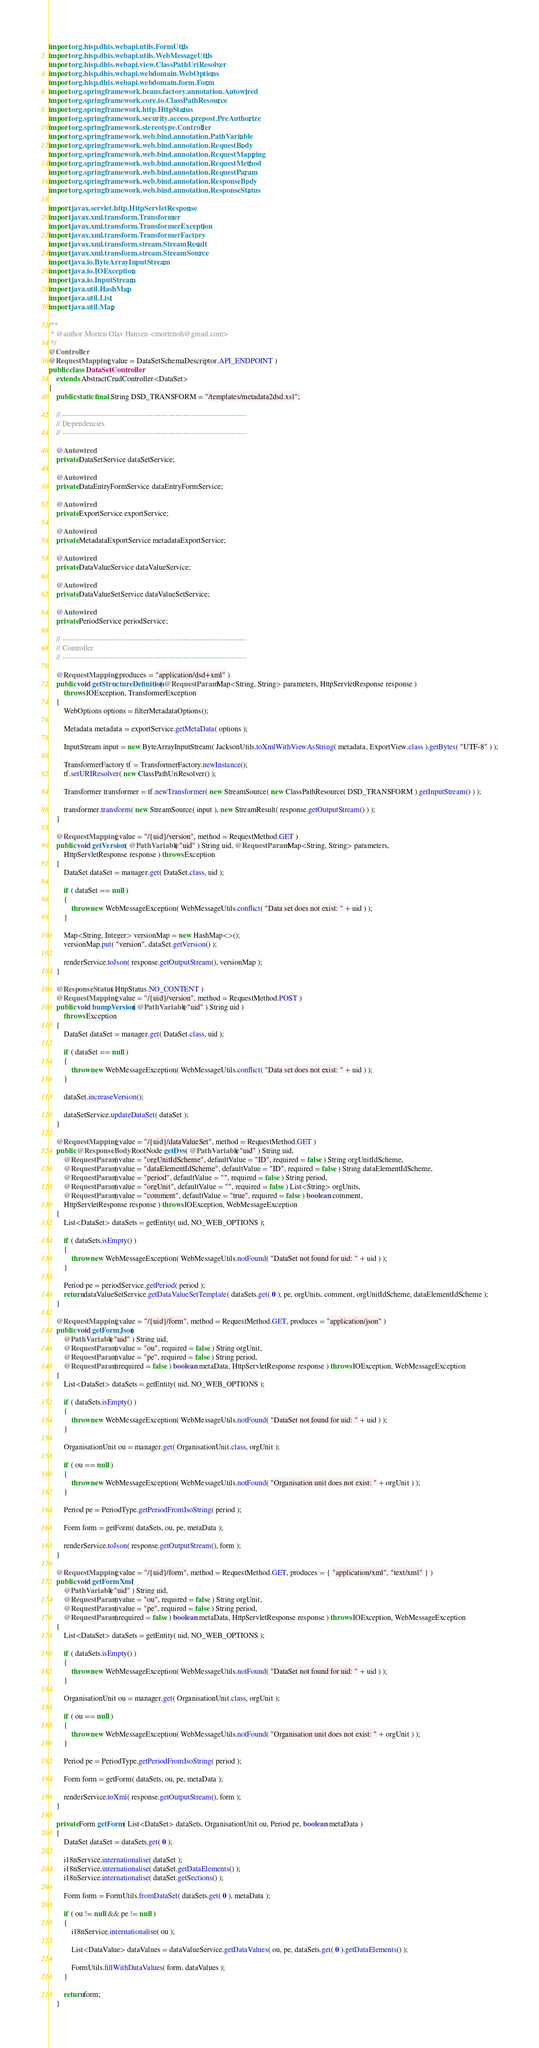Convert code to text. <code><loc_0><loc_0><loc_500><loc_500><_Java_>import org.hisp.dhis.webapi.utils.FormUtils;
import org.hisp.dhis.webapi.utils.WebMessageUtils;
import org.hisp.dhis.webapi.view.ClassPathUriResolver;
import org.hisp.dhis.webapi.webdomain.WebOptions;
import org.hisp.dhis.webapi.webdomain.form.Form;
import org.springframework.beans.factory.annotation.Autowired;
import org.springframework.core.io.ClassPathResource;
import org.springframework.http.HttpStatus;
import org.springframework.security.access.prepost.PreAuthorize;
import org.springframework.stereotype.Controller;
import org.springframework.web.bind.annotation.PathVariable;
import org.springframework.web.bind.annotation.RequestBody;
import org.springframework.web.bind.annotation.RequestMapping;
import org.springframework.web.bind.annotation.RequestMethod;
import org.springframework.web.bind.annotation.RequestParam;
import org.springframework.web.bind.annotation.ResponseBody;
import org.springframework.web.bind.annotation.ResponseStatus;

import javax.servlet.http.HttpServletResponse;
import javax.xml.transform.Transformer;
import javax.xml.transform.TransformerException;
import javax.xml.transform.TransformerFactory;
import javax.xml.transform.stream.StreamResult;
import javax.xml.transform.stream.StreamSource;
import java.io.ByteArrayInputStream;
import java.io.IOException;
import java.io.InputStream;
import java.util.HashMap;
import java.util.List;
import java.util.Map;

/**
 * @author Morten Olav Hansen <mortenoh@gmail.com>
 */
@Controller
@RequestMapping( value = DataSetSchemaDescriptor.API_ENDPOINT )
public class DataSetController
    extends AbstractCrudController<DataSet>
{
    public static final String DSD_TRANSFORM = "/templates/metadata2dsd.xsl";

    // -------------------------------------------------------------------------
    // Dependencies
    // -------------------------------------------------------------------------

    @Autowired
    private DataSetService dataSetService;

    @Autowired
    private DataEntryFormService dataEntryFormService;

    @Autowired
    private ExportService exportService;

    @Autowired
    private MetadataExportService metadataExportService;

    @Autowired
    private DataValueService dataValueService;

    @Autowired
    private DataValueSetService dataValueSetService;

    @Autowired
    private PeriodService periodService;

    // -------------------------------------------------------------------------
    // Controller
    // -------------------------------------------------------------------------

    @RequestMapping( produces = "application/dsd+xml" )
    public void getStructureDefinition( @RequestParam Map<String, String> parameters, HttpServletResponse response )
        throws IOException, TransformerException
    {
        WebOptions options = filterMetadataOptions();

        Metadata metadata = exportService.getMetaData( options );

        InputStream input = new ByteArrayInputStream( JacksonUtils.toXmlWithViewAsString( metadata, ExportView.class ).getBytes( "UTF-8" ) );

        TransformerFactory tf = TransformerFactory.newInstance();
        tf.setURIResolver( new ClassPathUriResolver() );

        Transformer transformer = tf.newTransformer( new StreamSource( new ClassPathResource( DSD_TRANSFORM ).getInputStream() ) );

        transformer.transform( new StreamSource( input ), new StreamResult( response.getOutputStream() ) );
    }

    @RequestMapping( value = "/{uid}/version", method = RequestMethod.GET )
    public void getVersion( @PathVariable( "uid" ) String uid, @RequestParam Map<String, String> parameters,
        HttpServletResponse response ) throws Exception
    {
        DataSet dataSet = manager.get( DataSet.class, uid );

        if ( dataSet == null )
        {
            throw new WebMessageException( WebMessageUtils.conflict( "Data set does not exist: " + uid ) );
        }
        
        Map<String, Integer> versionMap = new HashMap<>();
        versionMap.put( "version", dataSet.getVersion() );

        renderService.toJson( response.getOutputStream(), versionMap );
    }
    
    @ResponseStatus( HttpStatus.NO_CONTENT )
    @RequestMapping( value = "/{uid}/version", method = RequestMethod.POST )
    public void bumpVersion( @PathVariable( "uid" ) String uid )
        throws Exception
    {
        DataSet dataSet = manager.get( DataSet.class, uid );

        if ( dataSet == null )
        {
            throw new WebMessageException( WebMessageUtils.conflict( "Data set does not exist: " + uid ) );
        }
        
        dataSet.increaseVersion();
        
        dataSetService.updateDataSet( dataSet );
    }

    @RequestMapping( value = "/{uid}/dataValueSet", method = RequestMethod.GET )
    public @ResponseBody RootNode getDvs( @PathVariable( "uid" ) String uid,
        @RequestParam( value = "orgUnitIdScheme", defaultValue = "ID", required = false ) String orgUnitIdScheme,
        @RequestParam( value = "dataElementIdScheme", defaultValue = "ID", required = false ) String dataElementIdScheme,
        @RequestParam( value = "period", defaultValue = "", required = false ) String period,
        @RequestParam( value = "orgUnit", defaultValue = "", required = false ) List<String> orgUnits,
        @RequestParam( value = "comment", defaultValue = "true", required = false ) boolean comment,
        HttpServletResponse response ) throws IOException, WebMessageException
    {
        List<DataSet> dataSets = getEntity( uid, NO_WEB_OPTIONS );

        if ( dataSets.isEmpty() )
        {
            throw new WebMessageException( WebMessageUtils.notFound( "DataSet not found for uid: " + uid ) );
        }

        Period pe = periodService.getPeriod( period );
        return dataValueSetService.getDataValueSetTemplate( dataSets.get( 0 ), pe, orgUnits, comment, orgUnitIdScheme, dataElementIdScheme );
    }

    @RequestMapping( value = "/{uid}/form", method = RequestMethod.GET, produces = "application/json" )
    public void getFormJson(
        @PathVariable( "uid" ) String uid,
        @RequestParam( value = "ou", required = false ) String orgUnit,
        @RequestParam( value = "pe", required = false ) String period,
        @RequestParam( required = false ) boolean metaData, HttpServletResponse response ) throws IOException, WebMessageException
    {
        List<DataSet> dataSets = getEntity( uid, NO_WEB_OPTIONS );

        if ( dataSets.isEmpty() )
        {
            throw new WebMessageException( WebMessageUtils.notFound( "DataSet not found for uid: " + uid ) );
        }

        OrganisationUnit ou = manager.get( OrganisationUnit.class, orgUnit );

        if ( ou == null )
        {
            throw new WebMessageException( WebMessageUtils.notFound( "Organisation unit does not exist: " + orgUnit ) );
        }

        Period pe = PeriodType.getPeriodFromIsoString( period );

        Form form = getForm( dataSets, ou, pe, metaData );

        renderService.toJson( response.getOutputStream(), form );
    }

    @RequestMapping( value = "/{uid}/form", method = RequestMethod.GET, produces = { "application/xml", "text/xml" } )
    public void getFormXml(
        @PathVariable( "uid" ) String uid,
        @RequestParam( value = "ou", required = false ) String orgUnit,
        @RequestParam( value = "pe", required = false ) String period,
        @RequestParam( required = false ) boolean metaData, HttpServletResponse response ) throws IOException, WebMessageException
    {
        List<DataSet> dataSets = getEntity( uid, NO_WEB_OPTIONS );

        if ( dataSets.isEmpty() )
        {
            throw new WebMessageException( WebMessageUtils.notFound( "DataSet not found for uid: " + uid ) );
        }

        OrganisationUnit ou = manager.get( OrganisationUnit.class, orgUnit );

        if ( ou == null )
        {
            throw new WebMessageException( WebMessageUtils.notFound( "Organisation unit does not exist: " + orgUnit ) );
        }

        Period pe = PeriodType.getPeriodFromIsoString( period );

        Form form = getForm( dataSets, ou, pe, metaData );

        renderService.toXml( response.getOutputStream(), form );
    }

    private Form getForm( List<DataSet> dataSets, OrganisationUnit ou, Period pe, boolean metaData )
    {
        DataSet dataSet = dataSets.get( 0 );

        i18nService.internationalise( dataSet );
        i18nService.internationalise( dataSet.getDataElements() );
        i18nService.internationalise( dataSet.getSections() );

        Form form = FormUtils.fromDataSet( dataSets.get( 0 ), metaData );

        if ( ou != null && pe != null )
        {
            i18nService.internationalise( ou );

            List<DataValue> dataValues = dataValueService.getDataValues( ou, pe, dataSets.get( 0 ).getDataElements() );

            FormUtils.fillWithDataValues( form, dataValues );
        }

        return form;
    }
</code> 